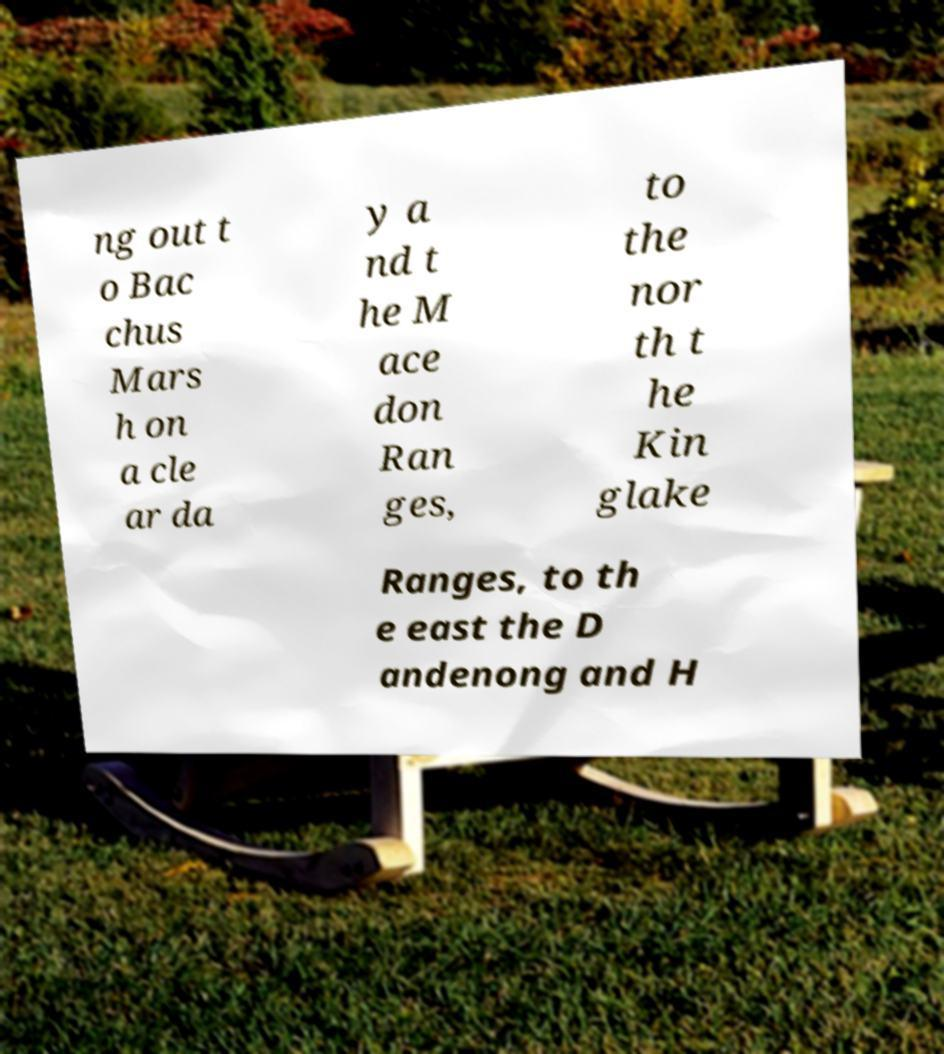Please read and relay the text visible in this image. What does it say? ng out t o Bac chus Mars h on a cle ar da y a nd t he M ace don Ran ges, to the nor th t he Kin glake Ranges, to th e east the D andenong and H 